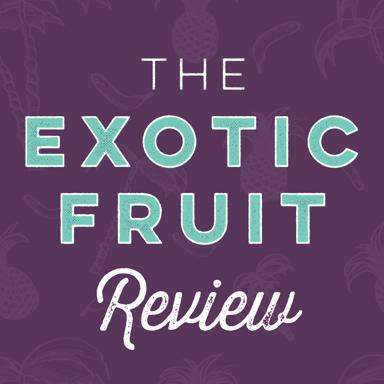What could the purpose of this image be? The purpose of this image is likely to attract the attention of readers or viewers to an article, blog post, or magazine feature about exotic fruits. Its compelling design, featuring a large, ripe pineapple and engaging text, makes it ideal for use in marketing or educational materials aimed at fruit enthusiasts or culinary explorers. 